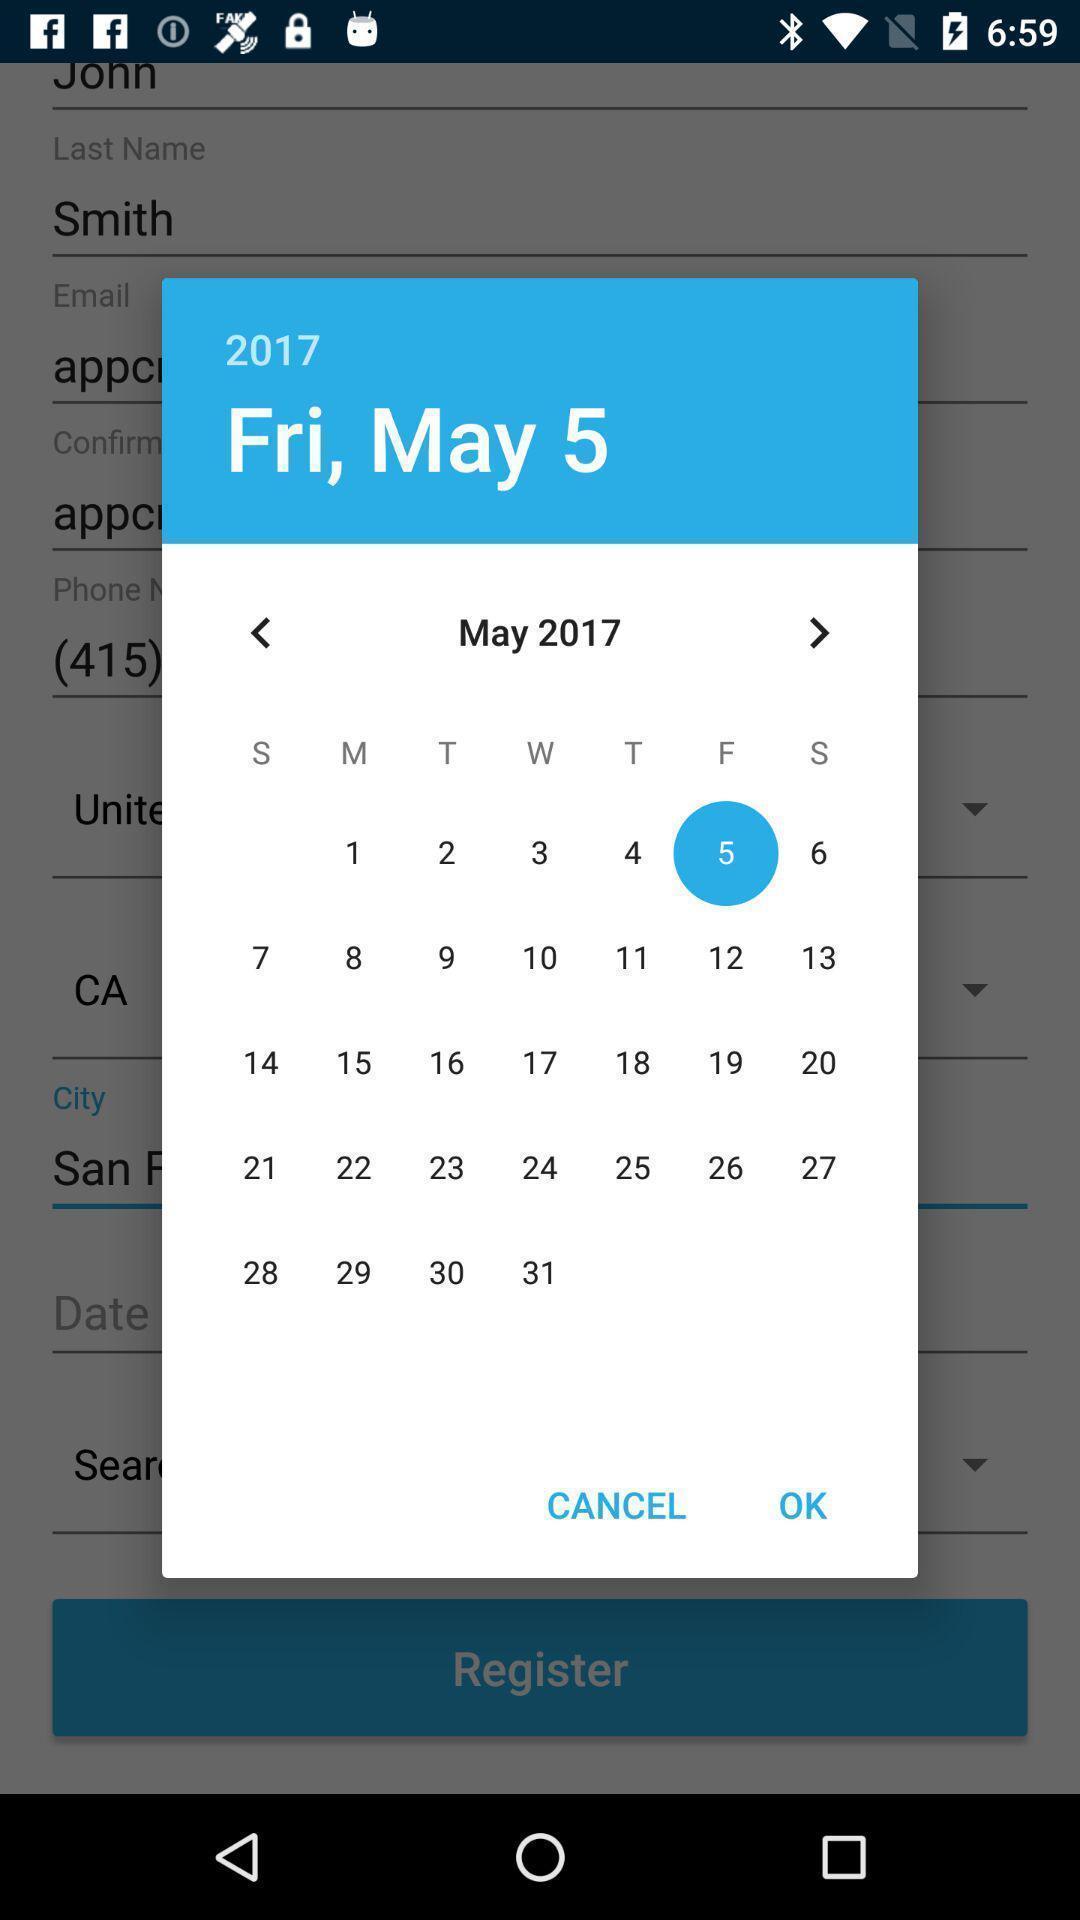Explain what's happening in this screen capture. Pop-up for selecting date in a calendar. 